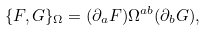Convert formula to latex. <formula><loc_0><loc_0><loc_500><loc_500>\{ F , G \} _ { \Omega } = ( \partial _ { a } F ) \Omega ^ { a b } ( \partial _ { b } G ) ,</formula> 